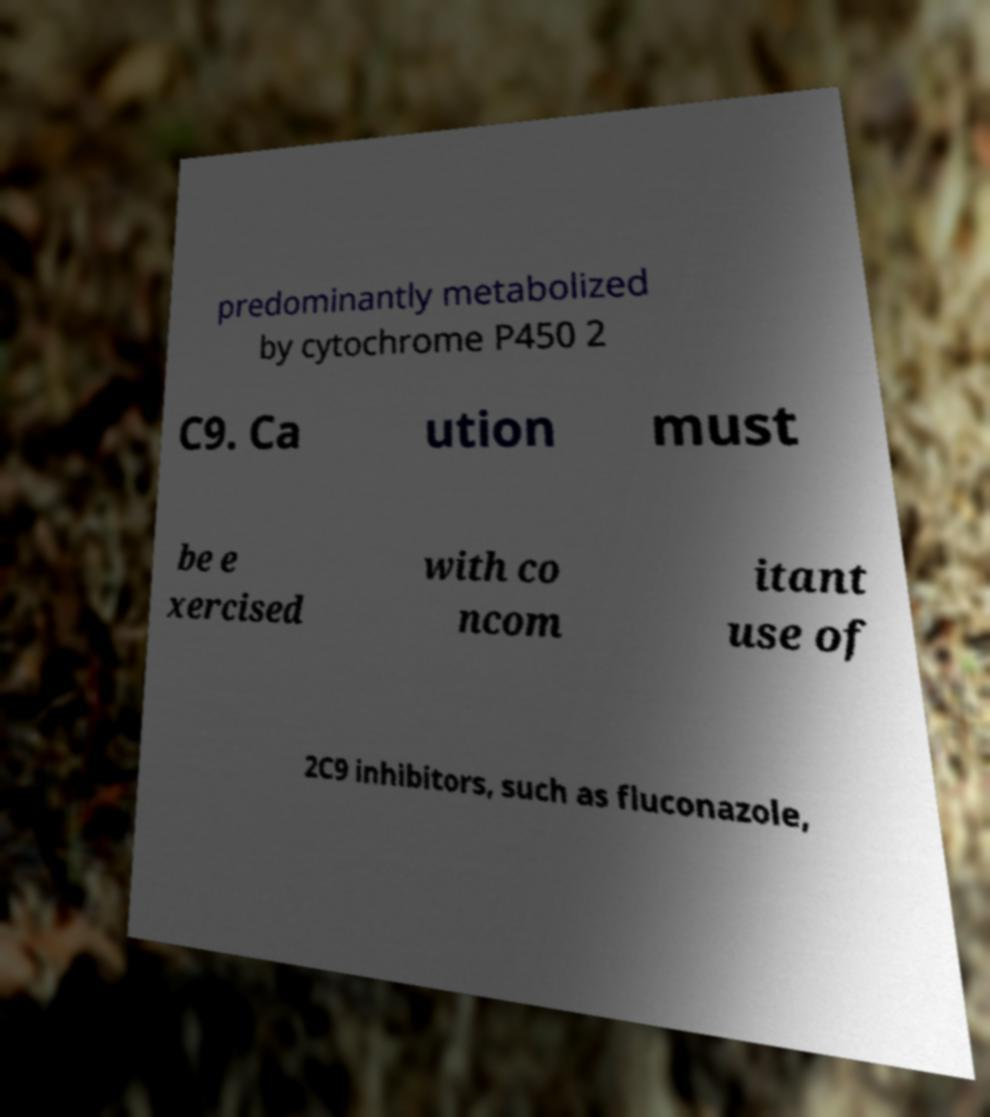For documentation purposes, I need the text within this image transcribed. Could you provide that? predominantly metabolized by cytochrome P450 2 C9. Ca ution must be e xercised with co ncom itant use of 2C9 inhibitors, such as fluconazole, 